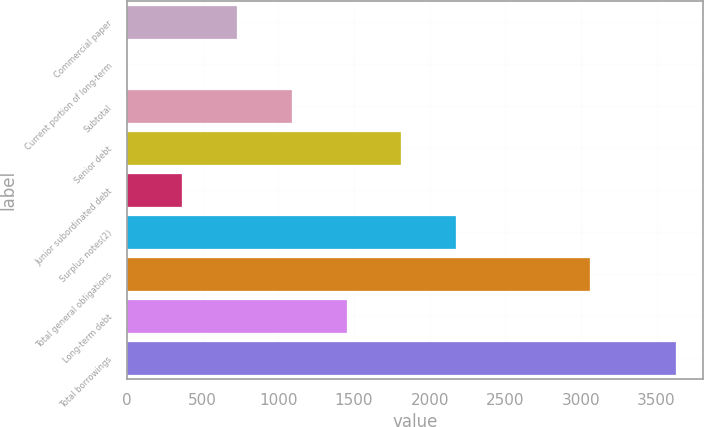<chart> <loc_0><loc_0><loc_500><loc_500><bar_chart><fcel>Commercial paper<fcel>Current portion of long-term<fcel>Subtotal<fcel>Senior debt<fcel>Junior subordinated debt<fcel>Surplus notes(2)<fcel>Total general obligations<fcel>Long-term debt<fcel>Total borrowings<nl><fcel>725.8<fcel>1<fcel>1088.2<fcel>1813<fcel>363.4<fcel>2175.4<fcel>3060<fcel>1450.6<fcel>3625<nl></chart> 